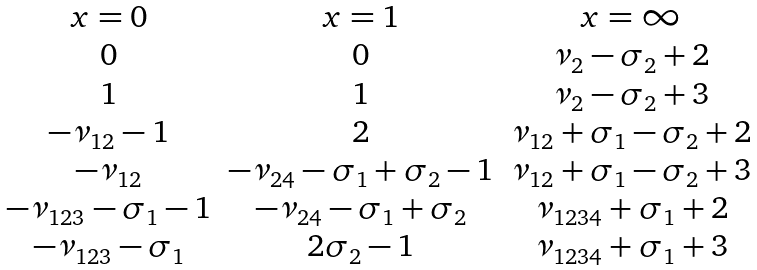<formula> <loc_0><loc_0><loc_500><loc_500>\begin{matrix} x = 0 & x = 1 & x = \infty \\ 0 & 0 & \nu _ { 2 } - \sigma _ { 2 } + 2 \\ 1 & 1 & \nu _ { 2 } - \sigma _ { 2 } + 3 \\ - \nu _ { 1 2 } - 1 & 2 & \nu _ { 1 2 } + \sigma _ { 1 } - \sigma _ { 2 } + 2 \\ - \nu _ { 1 2 } & - \nu _ { 2 4 } - \sigma _ { 1 } + \sigma _ { 2 } - 1 & \nu _ { 1 2 } + \sigma _ { 1 } - \sigma _ { 2 } + 3 \\ - \nu _ { 1 2 3 } - \sigma _ { 1 } - 1 & - \nu _ { 2 4 } - \sigma _ { 1 } + \sigma _ { 2 } & \nu _ { 1 2 3 4 } + \sigma _ { 1 } + 2 \\ - \nu _ { 1 2 3 } - \sigma _ { 1 } & 2 \sigma _ { 2 } - 1 & \nu _ { 1 2 3 4 } + \sigma _ { 1 } + 3 \end{matrix}</formula> 